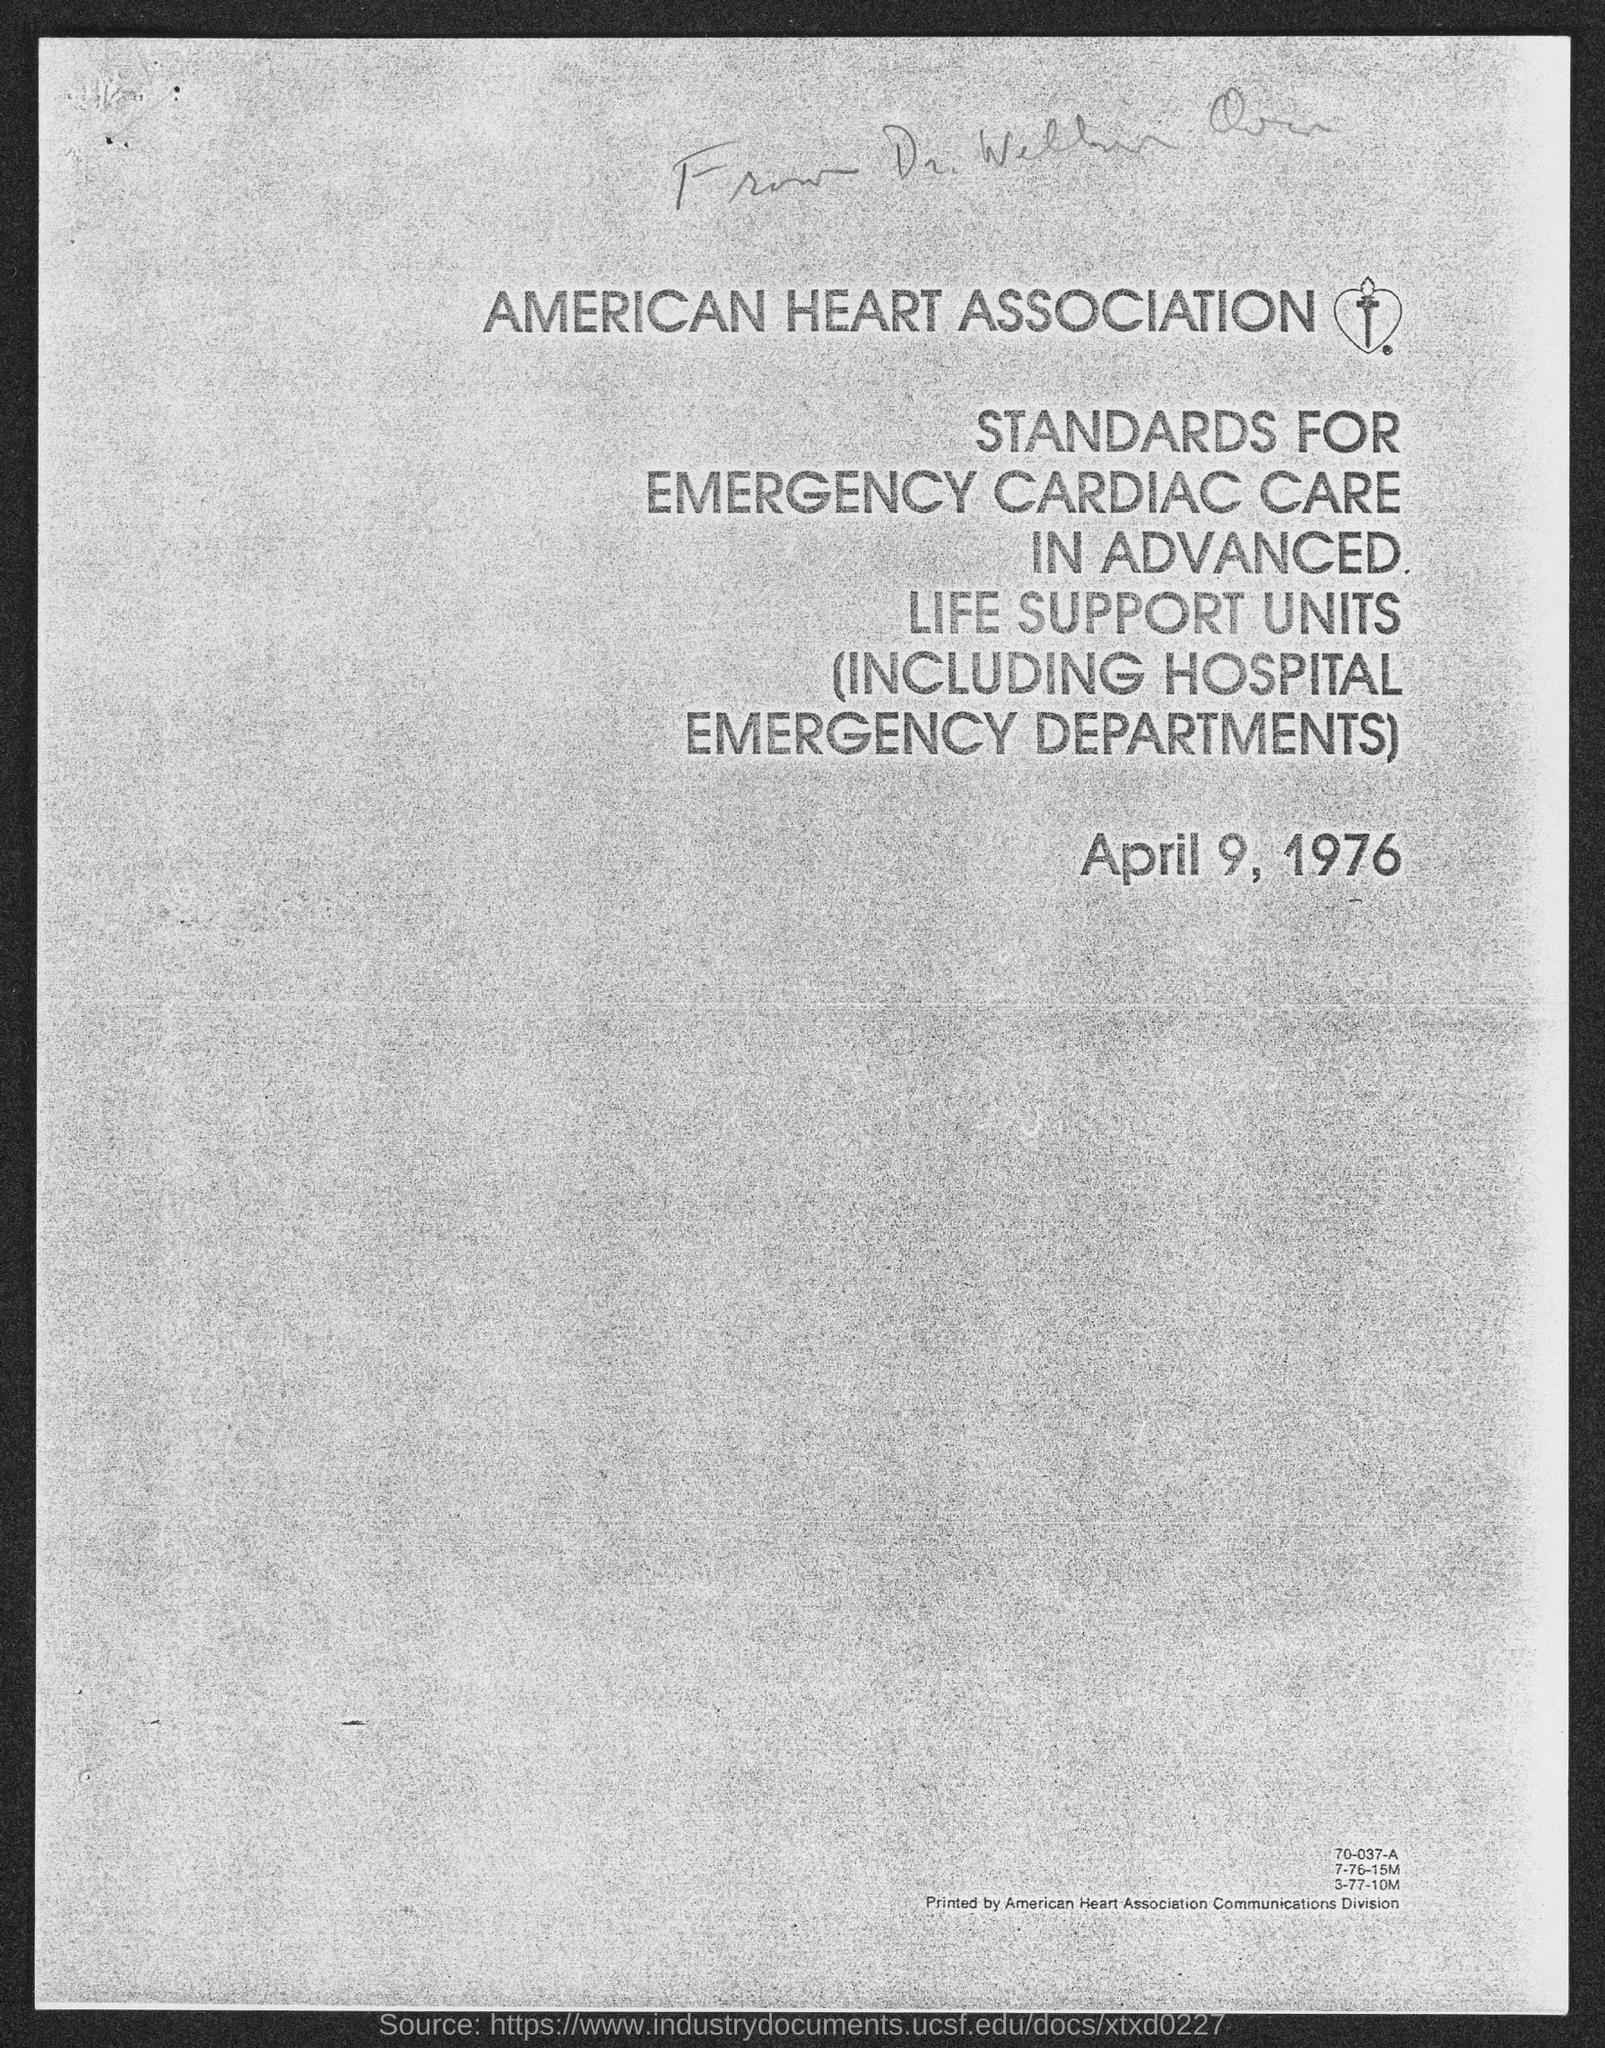Give some essential details in this illustration. The name of the health association is the American Heart Association. 